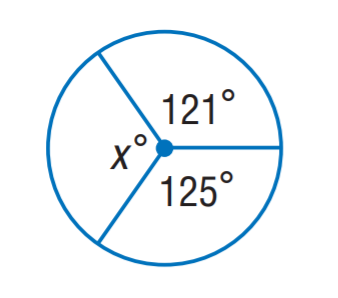Answer the mathemtical geometry problem and directly provide the correct option letter.
Question: Find x.
Choices: A: 114 B: 118 C: 121 D: 125 A 